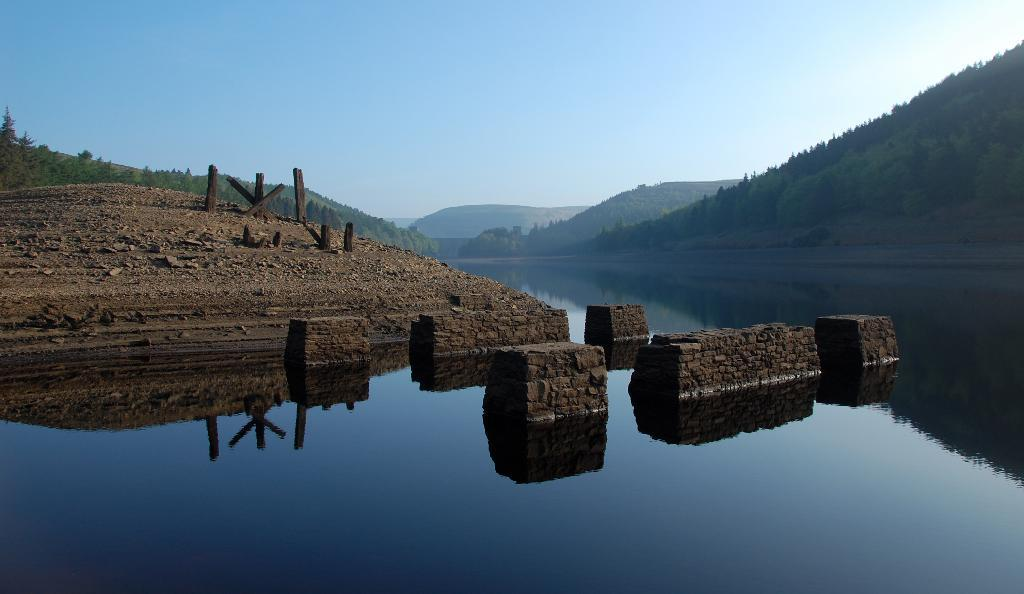What type of natural feature can be seen in the picture? There is a river in the picture. What other natural feature is present in the image? There is a mountain in the picture. How are the mountains described in the image? The mountains are covered with trees. What is the condition of the sky in the picture? The sky is clear in the picture. What type of creature can be seen swimming in the river in the image? There is no creature visible in the river in the image. What type of treatment is being administered to the mountain in the image? There is no treatment being administered to the mountain in the image; it is a natural feature. 